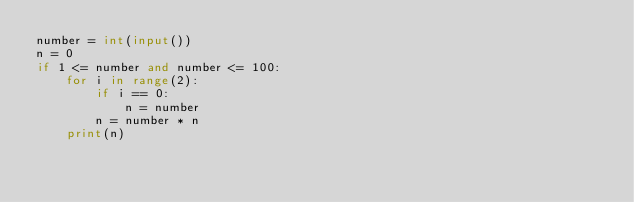<code> <loc_0><loc_0><loc_500><loc_500><_Python_>number = int(input())
n = 0
if 1 <= number and number <= 100:
    for i in range(2):
        if i == 0:
            n = number
        n = number * n
    print(n)

</code> 